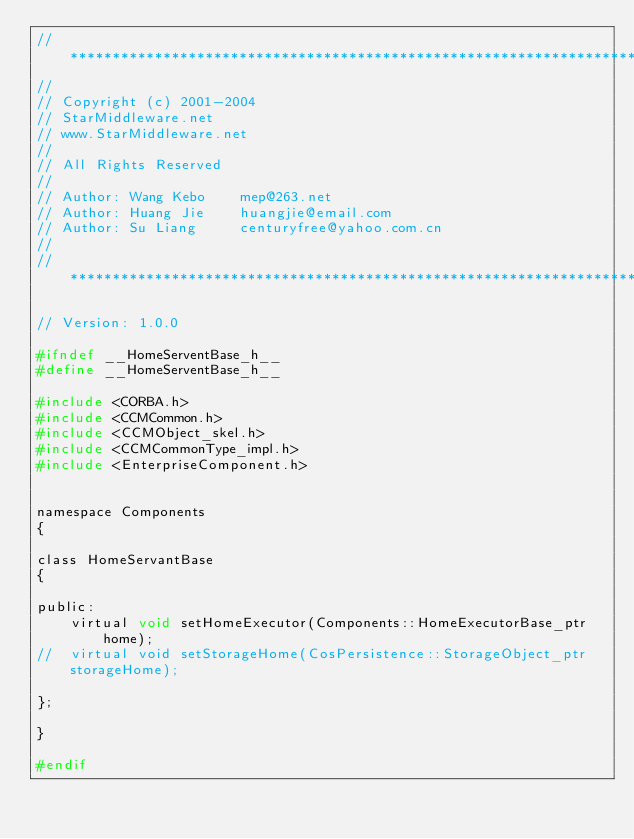<code> <loc_0><loc_0><loc_500><loc_500><_C_>// **********************************************************************
//
// Copyright (c) 2001-2004
// StarMiddleware.net
// www.StarMiddleware.net
//
// All Rights Reserved
//
// Author: Wang Kebo    mep@263.net
// Author: Huang Jie    huangjie@email.com
// Author: Su Liang     centuryfree@yahoo.com.cn
//
// **********************************************************************

// Version: 1.0.0

#ifndef __HomeServentBase_h__
#define __HomeServentBase_h__

#include <CORBA.h>
#include <CCMCommon.h>
#include <CCMObject_skel.h>
#include <CCMCommonType_impl.h>
#include <EnterpriseComponent.h>


namespace Components
{

class HomeServantBase
{

public:
	virtual void setHomeExecutor(Components::HomeExecutorBase_ptr home);
//	virtual void setStorageHome(CosPersistence::StorageObject_ptr storageHome);
	
};
	
}

#endif

</code> 